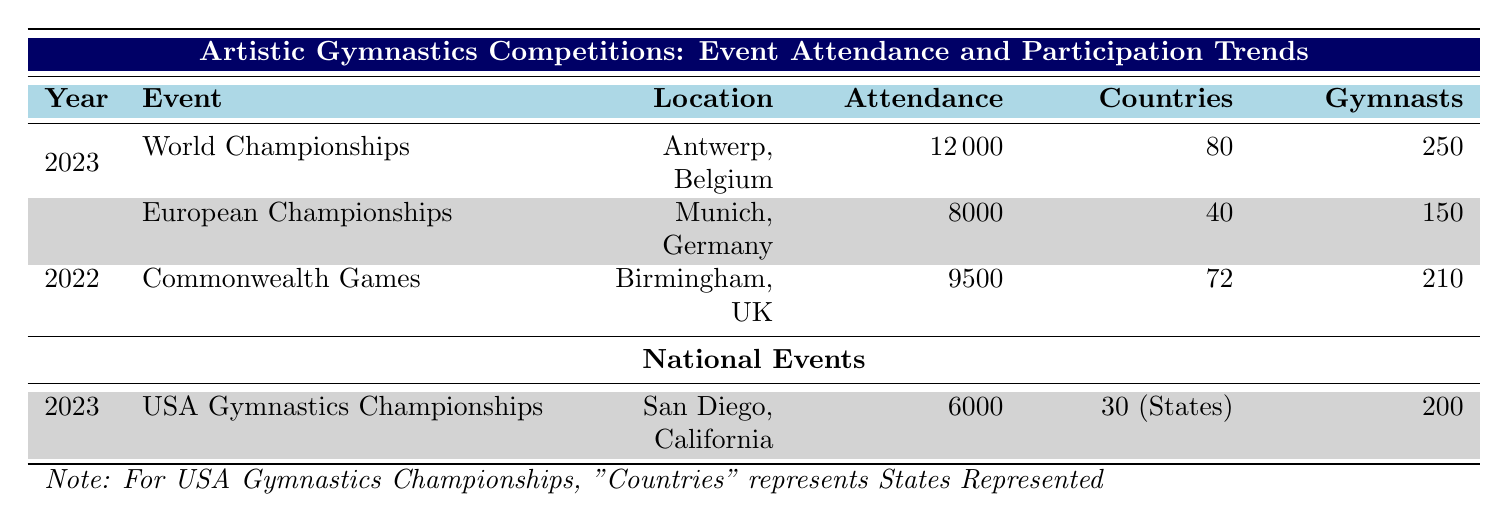What was the attendance at the World Championships in 2023? The attendance for the World Championships in 2023 is listed directly in the table under the corresponding event row, which indicates an attendance of 12,000.
Answer: 12000 How many countries participated in the European Championships in 2023? The table specifies that there were 40 countries participating in the European Championships in 2023, as seen in the relevant row.
Answer: 40 What is the total attendance for all the events listed in 2023? To find the total attendance for 2023, I sum the attendance from both events: 12,000 (World Championships) + 8,000 (European Championships) = 20,000.
Answer: 20000 Did the number of participants in the Commonwealth Games in 2022 exceed those in the USA Gymnastics Championships in 2023? The Commonwealth Games had 210 participants, while the USA Gymnastics Championships had 200 participants. Since 210 is greater than 200, the statement is true.
Answer: Yes How many male gymnasts participated in the World Championships in 2023? The Gender Distribution section for the World Championships in 2023 shows that there were 120 male gymnasts participating, which is directly stated in the table.
Answer: 120 What is the difference in attendance between the Commonwealth Games in 2022 and the European Championships in 2023? To find the difference in attendance, I subtract the attendance of the European Championships (8,000) from the Commonwealth Games (9,500): 9,500 - 8,000 = 1,500.
Answer: 1500 Which event held in 2023 had the highest number of gymnasts participating? The World Championships in 2023 had 250 gymnasts, which is the highest compared to the 150 participants at the European Championships in 2023, therefore the World Championships had the most participants.
Answer: World Championships What were the locations of the events held in 2023? The World Championships took place in Antwerp, Belgium, and the European Championships were held in Munich, Germany, as indicated in the “Location” column for each event in 2023.
Answer: Antwerp, Belgium and Munich, Germany How many female gymnasts participated in the USA Gymnastics Championships in 2023? The Gender Distribution for the USA Gymnastics Championships in 2023 indicates there were 110 female gymnasts, as listed in the table under the respective section.
Answer: 110 